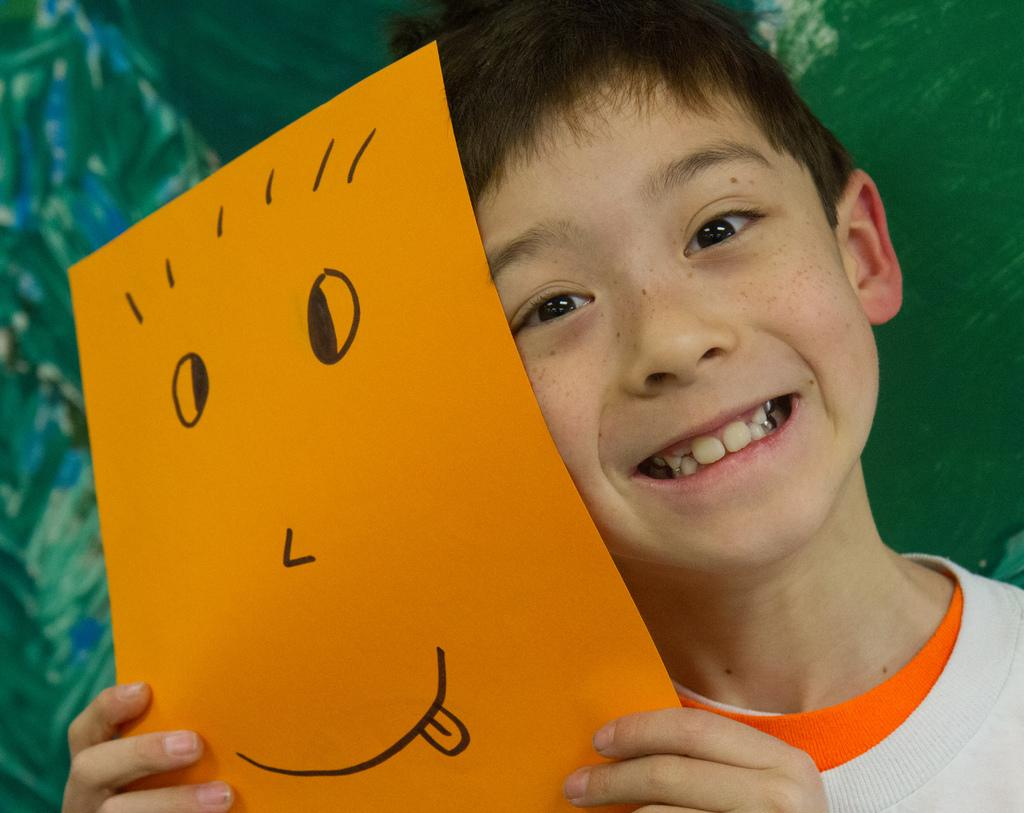Who is present in the image? There is a boy in the image. What is the boy holding in the image? The boy is holding a yellow paper. Can you describe the drawing on the paper? There is a smile drawn on the paper. What type of insurance policy is the boy discussing in the image? There is no indication of any insurance policy being discussed in the image. 